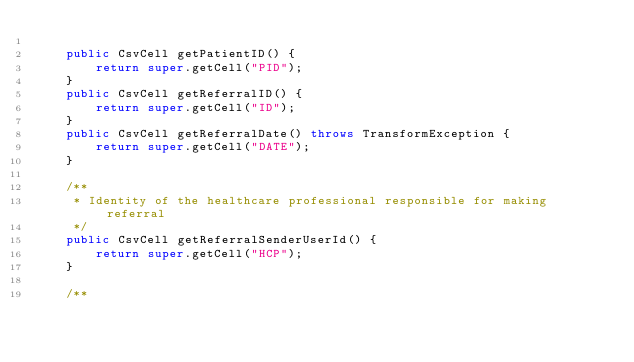<code> <loc_0><loc_0><loc_500><loc_500><_Java_>
    public CsvCell getPatientID() {
        return super.getCell("PID");
    }
    public CsvCell getReferralID() {
        return super.getCell("ID");
    }
    public CsvCell getReferralDate() throws TransformException {
        return super.getCell("DATE");
    }

    /**
     * Identity of the healthcare professional responsible for making referral
     */
    public CsvCell getReferralSenderUserId() {
        return super.getCell("HCP");
    }

    /**</code> 